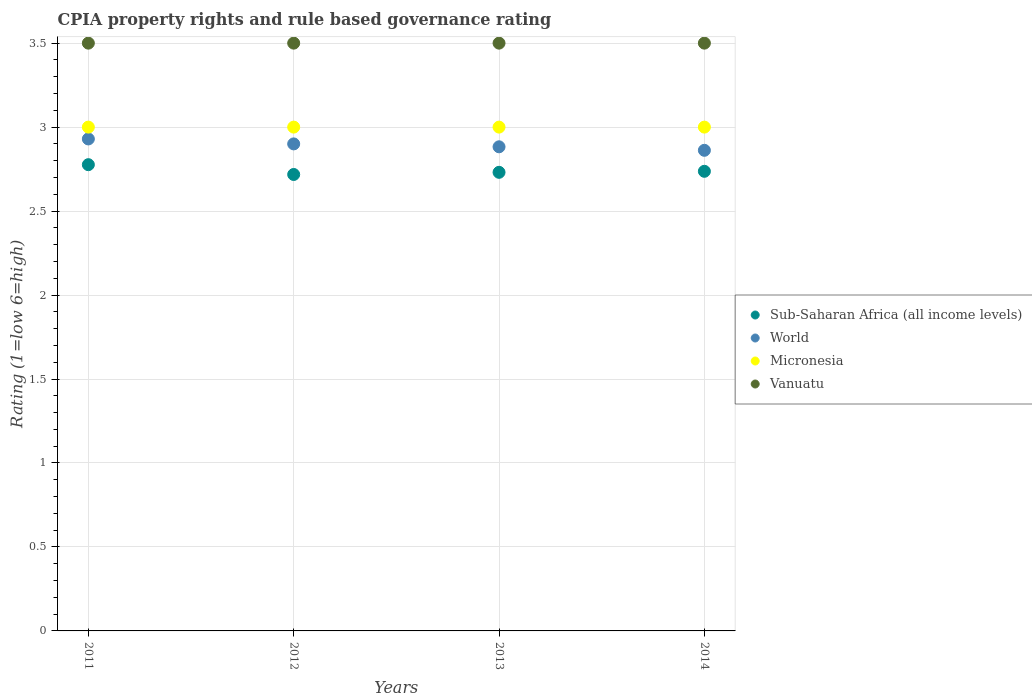How many different coloured dotlines are there?
Your answer should be compact. 4. Is the number of dotlines equal to the number of legend labels?
Offer a very short reply. Yes. What is the CPIA rating in Micronesia in 2012?
Make the answer very short. 3. Across all years, what is the minimum CPIA rating in Micronesia?
Offer a terse response. 3. In which year was the CPIA rating in Vanuatu maximum?
Your answer should be very brief. 2011. In which year was the CPIA rating in Sub-Saharan Africa (all income levels) minimum?
Provide a succinct answer. 2012. What is the total CPIA rating in Sub-Saharan Africa (all income levels) in the graph?
Give a very brief answer. 10.96. What is the difference between the CPIA rating in Sub-Saharan Africa (all income levels) in 2012 and that in 2013?
Provide a succinct answer. -0.01. What is the difference between the CPIA rating in World in 2011 and the CPIA rating in Micronesia in 2014?
Make the answer very short. -0.07. What is the average CPIA rating in Micronesia per year?
Your response must be concise. 3. In the year 2014, what is the difference between the CPIA rating in Vanuatu and CPIA rating in World?
Make the answer very short. 0.64. In how many years, is the CPIA rating in Micronesia greater than 2.7?
Keep it short and to the point. 4. What is the ratio of the CPIA rating in Micronesia in 2011 to that in 2013?
Keep it short and to the point. 1. What is the difference between the highest and the lowest CPIA rating in Micronesia?
Make the answer very short. 0. In how many years, is the CPIA rating in World greater than the average CPIA rating in World taken over all years?
Your answer should be compact. 2. Is it the case that in every year, the sum of the CPIA rating in Sub-Saharan Africa (all income levels) and CPIA rating in World  is greater than the sum of CPIA rating in Micronesia and CPIA rating in Vanuatu?
Your answer should be very brief. No. What is the difference between two consecutive major ticks on the Y-axis?
Offer a terse response. 0.5. Does the graph contain any zero values?
Your answer should be compact. No. Does the graph contain grids?
Ensure brevity in your answer.  Yes. How many legend labels are there?
Provide a succinct answer. 4. How are the legend labels stacked?
Give a very brief answer. Vertical. What is the title of the graph?
Offer a very short reply. CPIA property rights and rule based governance rating. What is the label or title of the X-axis?
Offer a very short reply. Years. What is the Rating (1=low 6=high) in Sub-Saharan Africa (all income levels) in 2011?
Give a very brief answer. 2.78. What is the Rating (1=low 6=high) in World in 2011?
Offer a very short reply. 2.93. What is the Rating (1=low 6=high) in Micronesia in 2011?
Offer a terse response. 3. What is the Rating (1=low 6=high) in Sub-Saharan Africa (all income levels) in 2012?
Provide a short and direct response. 2.72. What is the Rating (1=low 6=high) of Sub-Saharan Africa (all income levels) in 2013?
Keep it short and to the point. 2.73. What is the Rating (1=low 6=high) in World in 2013?
Your answer should be compact. 2.88. What is the Rating (1=low 6=high) of Micronesia in 2013?
Ensure brevity in your answer.  3. What is the Rating (1=low 6=high) of Sub-Saharan Africa (all income levels) in 2014?
Give a very brief answer. 2.74. What is the Rating (1=low 6=high) in World in 2014?
Offer a terse response. 2.86. What is the Rating (1=low 6=high) in Vanuatu in 2014?
Offer a very short reply. 3.5. Across all years, what is the maximum Rating (1=low 6=high) in Sub-Saharan Africa (all income levels)?
Offer a terse response. 2.78. Across all years, what is the maximum Rating (1=low 6=high) in World?
Your response must be concise. 2.93. Across all years, what is the maximum Rating (1=low 6=high) of Vanuatu?
Your answer should be very brief. 3.5. Across all years, what is the minimum Rating (1=low 6=high) in Sub-Saharan Africa (all income levels)?
Ensure brevity in your answer.  2.72. Across all years, what is the minimum Rating (1=low 6=high) of World?
Ensure brevity in your answer.  2.86. Across all years, what is the minimum Rating (1=low 6=high) of Micronesia?
Provide a short and direct response. 3. Across all years, what is the minimum Rating (1=low 6=high) of Vanuatu?
Your answer should be compact. 3.5. What is the total Rating (1=low 6=high) in Sub-Saharan Africa (all income levels) in the graph?
Keep it short and to the point. 10.96. What is the total Rating (1=low 6=high) of World in the graph?
Offer a very short reply. 11.57. What is the total Rating (1=low 6=high) in Micronesia in the graph?
Ensure brevity in your answer.  12. What is the difference between the Rating (1=low 6=high) in Sub-Saharan Africa (all income levels) in 2011 and that in 2012?
Your answer should be compact. 0.06. What is the difference between the Rating (1=low 6=high) in World in 2011 and that in 2012?
Keep it short and to the point. 0.03. What is the difference between the Rating (1=low 6=high) in Micronesia in 2011 and that in 2012?
Provide a succinct answer. 0. What is the difference between the Rating (1=low 6=high) in Sub-Saharan Africa (all income levels) in 2011 and that in 2013?
Make the answer very short. 0.05. What is the difference between the Rating (1=low 6=high) in World in 2011 and that in 2013?
Your answer should be compact. 0.05. What is the difference between the Rating (1=low 6=high) in Vanuatu in 2011 and that in 2013?
Offer a very short reply. 0. What is the difference between the Rating (1=low 6=high) of Sub-Saharan Africa (all income levels) in 2011 and that in 2014?
Your answer should be very brief. 0.04. What is the difference between the Rating (1=low 6=high) of World in 2011 and that in 2014?
Your answer should be compact. 0.07. What is the difference between the Rating (1=low 6=high) in Micronesia in 2011 and that in 2014?
Keep it short and to the point. 0. What is the difference between the Rating (1=low 6=high) of Vanuatu in 2011 and that in 2014?
Ensure brevity in your answer.  0. What is the difference between the Rating (1=low 6=high) of Sub-Saharan Africa (all income levels) in 2012 and that in 2013?
Provide a succinct answer. -0.01. What is the difference between the Rating (1=low 6=high) of World in 2012 and that in 2013?
Give a very brief answer. 0.02. What is the difference between the Rating (1=low 6=high) in Sub-Saharan Africa (all income levels) in 2012 and that in 2014?
Offer a terse response. -0.02. What is the difference between the Rating (1=low 6=high) in World in 2012 and that in 2014?
Your answer should be compact. 0.04. What is the difference between the Rating (1=low 6=high) of Micronesia in 2012 and that in 2014?
Your response must be concise. 0. What is the difference between the Rating (1=low 6=high) of Sub-Saharan Africa (all income levels) in 2013 and that in 2014?
Make the answer very short. -0.01. What is the difference between the Rating (1=low 6=high) in World in 2013 and that in 2014?
Provide a short and direct response. 0.02. What is the difference between the Rating (1=low 6=high) in Micronesia in 2013 and that in 2014?
Keep it short and to the point. 0. What is the difference between the Rating (1=low 6=high) in Vanuatu in 2013 and that in 2014?
Provide a succinct answer. 0. What is the difference between the Rating (1=low 6=high) in Sub-Saharan Africa (all income levels) in 2011 and the Rating (1=low 6=high) in World in 2012?
Your answer should be very brief. -0.12. What is the difference between the Rating (1=low 6=high) of Sub-Saharan Africa (all income levels) in 2011 and the Rating (1=low 6=high) of Micronesia in 2012?
Give a very brief answer. -0.22. What is the difference between the Rating (1=low 6=high) in Sub-Saharan Africa (all income levels) in 2011 and the Rating (1=low 6=high) in Vanuatu in 2012?
Make the answer very short. -0.72. What is the difference between the Rating (1=low 6=high) in World in 2011 and the Rating (1=low 6=high) in Micronesia in 2012?
Your answer should be very brief. -0.07. What is the difference between the Rating (1=low 6=high) of World in 2011 and the Rating (1=low 6=high) of Vanuatu in 2012?
Your answer should be very brief. -0.57. What is the difference between the Rating (1=low 6=high) of Micronesia in 2011 and the Rating (1=low 6=high) of Vanuatu in 2012?
Offer a very short reply. -0.5. What is the difference between the Rating (1=low 6=high) in Sub-Saharan Africa (all income levels) in 2011 and the Rating (1=low 6=high) in World in 2013?
Your response must be concise. -0.11. What is the difference between the Rating (1=low 6=high) in Sub-Saharan Africa (all income levels) in 2011 and the Rating (1=low 6=high) in Micronesia in 2013?
Ensure brevity in your answer.  -0.22. What is the difference between the Rating (1=low 6=high) of Sub-Saharan Africa (all income levels) in 2011 and the Rating (1=low 6=high) of Vanuatu in 2013?
Give a very brief answer. -0.72. What is the difference between the Rating (1=low 6=high) of World in 2011 and the Rating (1=low 6=high) of Micronesia in 2013?
Provide a short and direct response. -0.07. What is the difference between the Rating (1=low 6=high) in World in 2011 and the Rating (1=low 6=high) in Vanuatu in 2013?
Make the answer very short. -0.57. What is the difference between the Rating (1=low 6=high) of Sub-Saharan Africa (all income levels) in 2011 and the Rating (1=low 6=high) of World in 2014?
Provide a succinct answer. -0.09. What is the difference between the Rating (1=low 6=high) in Sub-Saharan Africa (all income levels) in 2011 and the Rating (1=low 6=high) in Micronesia in 2014?
Your answer should be very brief. -0.22. What is the difference between the Rating (1=low 6=high) of Sub-Saharan Africa (all income levels) in 2011 and the Rating (1=low 6=high) of Vanuatu in 2014?
Your response must be concise. -0.72. What is the difference between the Rating (1=low 6=high) in World in 2011 and the Rating (1=low 6=high) in Micronesia in 2014?
Your answer should be compact. -0.07. What is the difference between the Rating (1=low 6=high) of World in 2011 and the Rating (1=low 6=high) of Vanuatu in 2014?
Keep it short and to the point. -0.57. What is the difference between the Rating (1=low 6=high) of Micronesia in 2011 and the Rating (1=low 6=high) of Vanuatu in 2014?
Offer a very short reply. -0.5. What is the difference between the Rating (1=low 6=high) of Sub-Saharan Africa (all income levels) in 2012 and the Rating (1=low 6=high) of World in 2013?
Make the answer very short. -0.16. What is the difference between the Rating (1=low 6=high) of Sub-Saharan Africa (all income levels) in 2012 and the Rating (1=low 6=high) of Micronesia in 2013?
Keep it short and to the point. -0.28. What is the difference between the Rating (1=low 6=high) of Sub-Saharan Africa (all income levels) in 2012 and the Rating (1=low 6=high) of Vanuatu in 2013?
Provide a succinct answer. -0.78. What is the difference between the Rating (1=low 6=high) of World in 2012 and the Rating (1=low 6=high) of Micronesia in 2013?
Your answer should be compact. -0.1. What is the difference between the Rating (1=low 6=high) of World in 2012 and the Rating (1=low 6=high) of Vanuatu in 2013?
Make the answer very short. -0.6. What is the difference between the Rating (1=low 6=high) in Sub-Saharan Africa (all income levels) in 2012 and the Rating (1=low 6=high) in World in 2014?
Your response must be concise. -0.14. What is the difference between the Rating (1=low 6=high) of Sub-Saharan Africa (all income levels) in 2012 and the Rating (1=low 6=high) of Micronesia in 2014?
Offer a terse response. -0.28. What is the difference between the Rating (1=low 6=high) in Sub-Saharan Africa (all income levels) in 2012 and the Rating (1=low 6=high) in Vanuatu in 2014?
Your answer should be very brief. -0.78. What is the difference between the Rating (1=low 6=high) in Micronesia in 2012 and the Rating (1=low 6=high) in Vanuatu in 2014?
Your answer should be compact. -0.5. What is the difference between the Rating (1=low 6=high) of Sub-Saharan Africa (all income levels) in 2013 and the Rating (1=low 6=high) of World in 2014?
Ensure brevity in your answer.  -0.13. What is the difference between the Rating (1=low 6=high) of Sub-Saharan Africa (all income levels) in 2013 and the Rating (1=low 6=high) of Micronesia in 2014?
Offer a very short reply. -0.27. What is the difference between the Rating (1=low 6=high) of Sub-Saharan Africa (all income levels) in 2013 and the Rating (1=low 6=high) of Vanuatu in 2014?
Offer a very short reply. -0.77. What is the difference between the Rating (1=low 6=high) in World in 2013 and the Rating (1=low 6=high) in Micronesia in 2014?
Provide a succinct answer. -0.12. What is the difference between the Rating (1=low 6=high) in World in 2013 and the Rating (1=low 6=high) in Vanuatu in 2014?
Provide a succinct answer. -0.62. What is the difference between the Rating (1=low 6=high) of Micronesia in 2013 and the Rating (1=low 6=high) of Vanuatu in 2014?
Provide a succinct answer. -0.5. What is the average Rating (1=low 6=high) in Sub-Saharan Africa (all income levels) per year?
Your answer should be compact. 2.74. What is the average Rating (1=low 6=high) in World per year?
Your response must be concise. 2.89. What is the average Rating (1=low 6=high) in Micronesia per year?
Your answer should be compact. 3. What is the average Rating (1=low 6=high) of Vanuatu per year?
Offer a very short reply. 3.5. In the year 2011, what is the difference between the Rating (1=low 6=high) in Sub-Saharan Africa (all income levels) and Rating (1=low 6=high) in World?
Give a very brief answer. -0.15. In the year 2011, what is the difference between the Rating (1=low 6=high) of Sub-Saharan Africa (all income levels) and Rating (1=low 6=high) of Micronesia?
Your response must be concise. -0.22. In the year 2011, what is the difference between the Rating (1=low 6=high) in Sub-Saharan Africa (all income levels) and Rating (1=low 6=high) in Vanuatu?
Provide a succinct answer. -0.72. In the year 2011, what is the difference between the Rating (1=low 6=high) of World and Rating (1=low 6=high) of Micronesia?
Offer a very short reply. -0.07. In the year 2011, what is the difference between the Rating (1=low 6=high) of World and Rating (1=low 6=high) of Vanuatu?
Your answer should be very brief. -0.57. In the year 2011, what is the difference between the Rating (1=low 6=high) of Micronesia and Rating (1=low 6=high) of Vanuatu?
Your response must be concise. -0.5. In the year 2012, what is the difference between the Rating (1=low 6=high) of Sub-Saharan Africa (all income levels) and Rating (1=low 6=high) of World?
Ensure brevity in your answer.  -0.18. In the year 2012, what is the difference between the Rating (1=low 6=high) in Sub-Saharan Africa (all income levels) and Rating (1=low 6=high) in Micronesia?
Your answer should be compact. -0.28. In the year 2012, what is the difference between the Rating (1=low 6=high) of Sub-Saharan Africa (all income levels) and Rating (1=low 6=high) of Vanuatu?
Your answer should be very brief. -0.78. In the year 2012, what is the difference between the Rating (1=low 6=high) of Micronesia and Rating (1=low 6=high) of Vanuatu?
Your answer should be compact. -0.5. In the year 2013, what is the difference between the Rating (1=low 6=high) in Sub-Saharan Africa (all income levels) and Rating (1=low 6=high) in World?
Give a very brief answer. -0.15. In the year 2013, what is the difference between the Rating (1=low 6=high) in Sub-Saharan Africa (all income levels) and Rating (1=low 6=high) in Micronesia?
Your answer should be very brief. -0.27. In the year 2013, what is the difference between the Rating (1=low 6=high) of Sub-Saharan Africa (all income levels) and Rating (1=low 6=high) of Vanuatu?
Your answer should be compact. -0.77. In the year 2013, what is the difference between the Rating (1=low 6=high) in World and Rating (1=low 6=high) in Micronesia?
Ensure brevity in your answer.  -0.12. In the year 2013, what is the difference between the Rating (1=low 6=high) of World and Rating (1=low 6=high) of Vanuatu?
Provide a short and direct response. -0.62. In the year 2013, what is the difference between the Rating (1=low 6=high) of Micronesia and Rating (1=low 6=high) of Vanuatu?
Offer a very short reply. -0.5. In the year 2014, what is the difference between the Rating (1=low 6=high) in Sub-Saharan Africa (all income levels) and Rating (1=low 6=high) in World?
Offer a terse response. -0.12. In the year 2014, what is the difference between the Rating (1=low 6=high) in Sub-Saharan Africa (all income levels) and Rating (1=low 6=high) in Micronesia?
Provide a short and direct response. -0.26. In the year 2014, what is the difference between the Rating (1=low 6=high) in Sub-Saharan Africa (all income levels) and Rating (1=low 6=high) in Vanuatu?
Keep it short and to the point. -0.76. In the year 2014, what is the difference between the Rating (1=low 6=high) of World and Rating (1=low 6=high) of Micronesia?
Ensure brevity in your answer.  -0.14. In the year 2014, what is the difference between the Rating (1=low 6=high) in World and Rating (1=low 6=high) in Vanuatu?
Offer a terse response. -0.64. What is the ratio of the Rating (1=low 6=high) of Sub-Saharan Africa (all income levels) in 2011 to that in 2012?
Ensure brevity in your answer.  1.02. What is the ratio of the Rating (1=low 6=high) in World in 2011 to that in 2012?
Provide a succinct answer. 1.01. What is the ratio of the Rating (1=low 6=high) in Vanuatu in 2011 to that in 2012?
Give a very brief answer. 1. What is the ratio of the Rating (1=low 6=high) in Sub-Saharan Africa (all income levels) in 2011 to that in 2013?
Your answer should be compact. 1.02. What is the ratio of the Rating (1=low 6=high) in World in 2011 to that in 2013?
Your answer should be very brief. 1.02. What is the ratio of the Rating (1=low 6=high) in Vanuatu in 2011 to that in 2013?
Your answer should be compact. 1. What is the ratio of the Rating (1=low 6=high) of Sub-Saharan Africa (all income levels) in 2011 to that in 2014?
Your response must be concise. 1.01. What is the ratio of the Rating (1=low 6=high) in World in 2011 to that in 2014?
Your response must be concise. 1.02. What is the ratio of the Rating (1=low 6=high) in Micronesia in 2011 to that in 2014?
Provide a short and direct response. 1. What is the ratio of the Rating (1=low 6=high) of Sub-Saharan Africa (all income levels) in 2012 to that in 2013?
Keep it short and to the point. 1. What is the ratio of the Rating (1=low 6=high) in Micronesia in 2012 to that in 2013?
Your response must be concise. 1. What is the ratio of the Rating (1=low 6=high) in Vanuatu in 2012 to that in 2013?
Make the answer very short. 1. What is the ratio of the Rating (1=low 6=high) of World in 2012 to that in 2014?
Ensure brevity in your answer.  1.01. What is the ratio of the Rating (1=low 6=high) of Vanuatu in 2012 to that in 2014?
Keep it short and to the point. 1. What is the ratio of the Rating (1=low 6=high) of World in 2013 to that in 2014?
Offer a terse response. 1.01. What is the ratio of the Rating (1=low 6=high) in Micronesia in 2013 to that in 2014?
Make the answer very short. 1. What is the difference between the highest and the second highest Rating (1=low 6=high) in Sub-Saharan Africa (all income levels)?
Your response must be concise. 0.04. What is the difference between the highest and the second highest Rating (1=low 6=high) in World?
Your answer should be very brief. 0.03. What is the difference between the highest and the lowest Rating (1=low 6=high) of Sub-Saharan Africa (all income levels)?
Your response must be concise. 0.06. What is the difference between the highest and the lowest Rating (1=low 6=high) of World?
Your answer should be compact. 0.07. 